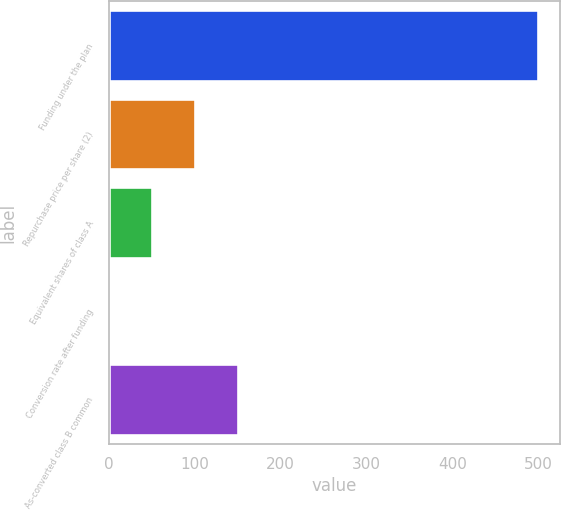<chart> <loc_0><loc_0><loc_500><loc_500><bar_chart><fcel>Funding under the plan<fcel>Repurchase price per share (2)<fcel>Equivalent shares of class A<fcel>Conversion rate after funding<fcel>As-converted class B common<nl><fcel>500<fcel>100.44<fcel>50.5<fcel>0.56<fcel>150.38<nl></chart> 